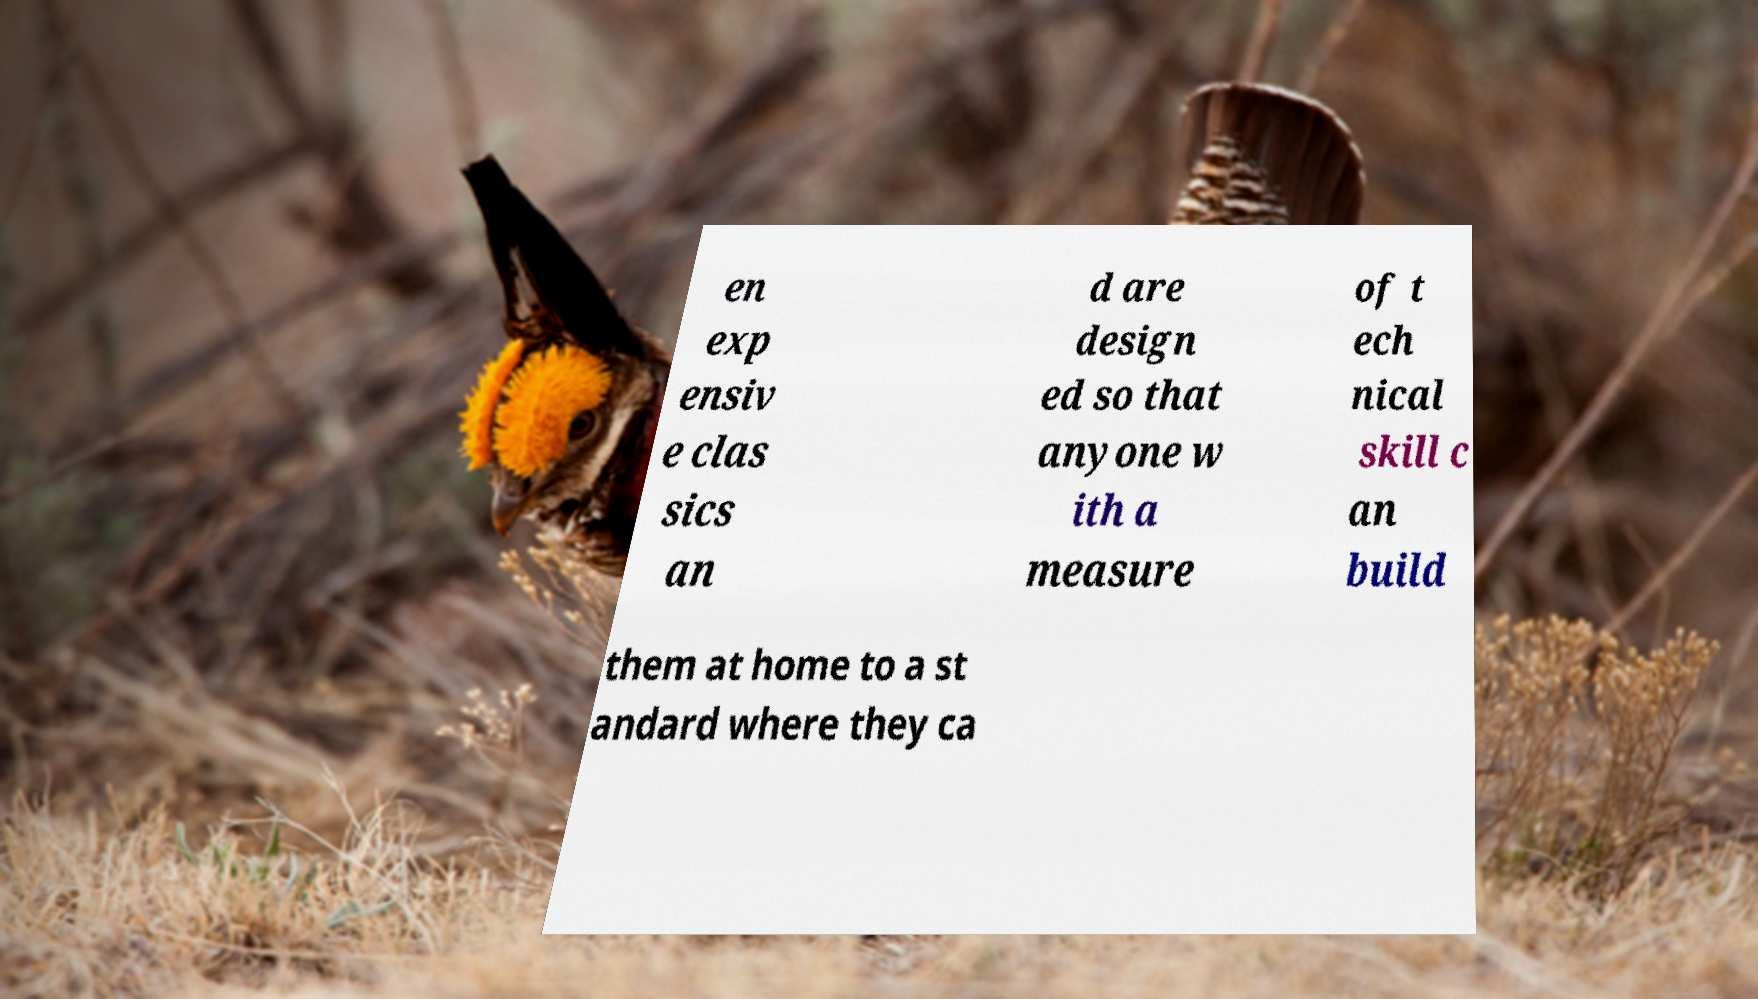Can you accurately transcribe the text from the provided image for me? en exp ensiv e clas sics an d are design ed so that anyone w ith a measure of t ech nical skill c an build them at home to a st andard where they ca 